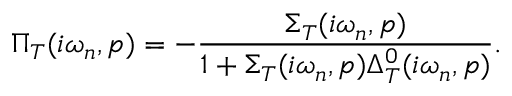<formula> <loc_0><loc_0><loc_500><loc_500>\Pi _ { T } ( i \omega _ { n } , p ) = - \frac { \Sigma _ { T } ( i \omega _ { n } , p ) } { 1 + \Sigma _ { T } ( i \omega _ { n } , p ) \Delta _ { T } ^ { 0 } ( i \omega _ { n } , p ) } .</formula> 